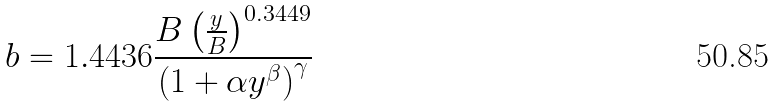<formula> <loc_0><loc_0><loc_500><loc_500>b = 1 . 4 4 3 6 \frac { B \left ( \frac { y } { B } \right ) ^ { 0 . 3 4 4 9 } } { \left ( 1 + \alpha y ^ { \beta } \right ) ^ { \gamma } }</formula> 